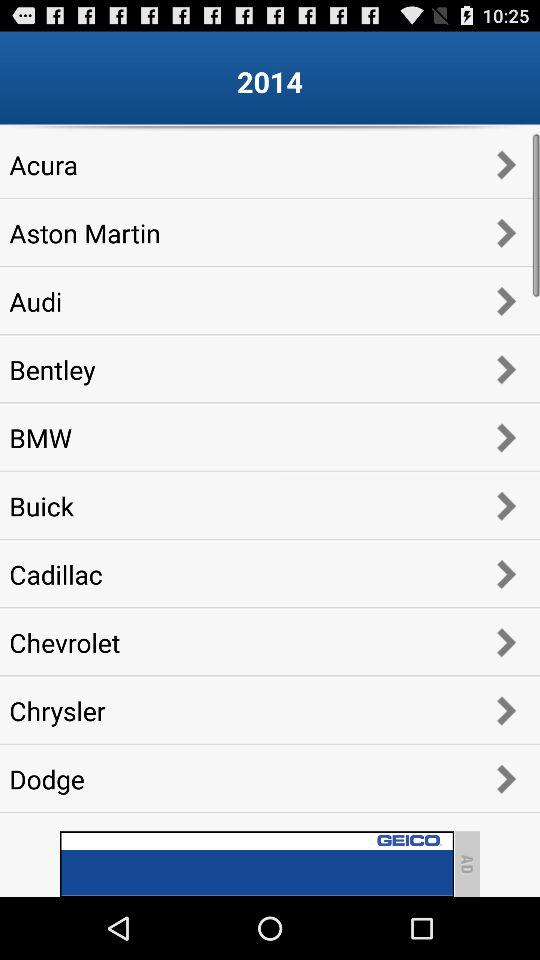How many items are in "Dodge"?
When the provided information is insufficient, respond with <no answer>. <no answer> 